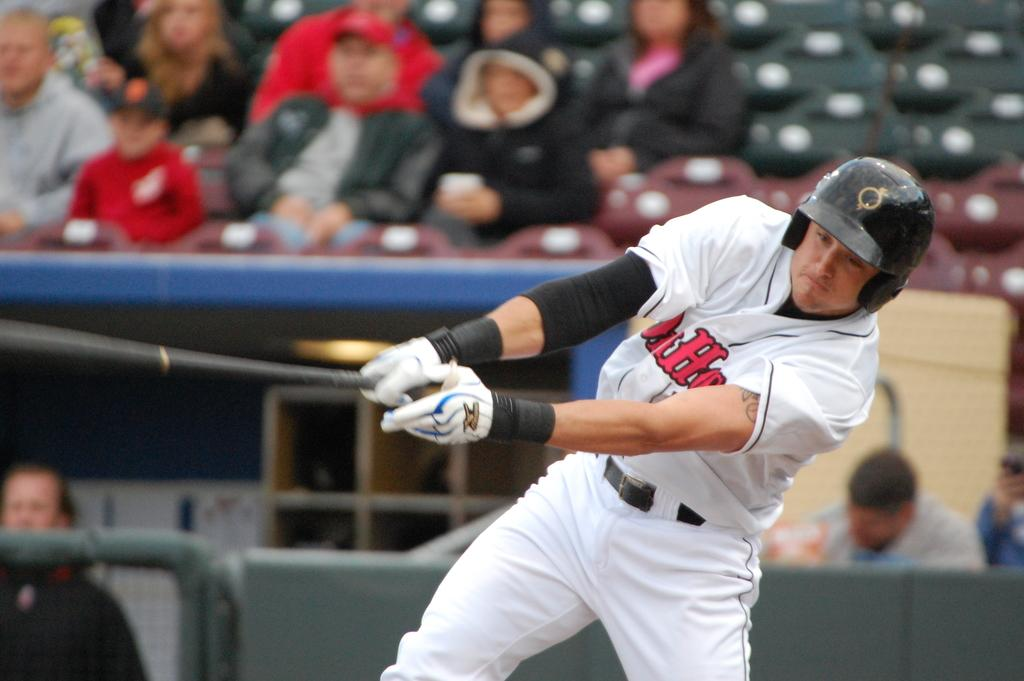<image>
Give a short and clear explanation of the subsequent image. the batter wears a jersey with a capital letter H in the front middle 